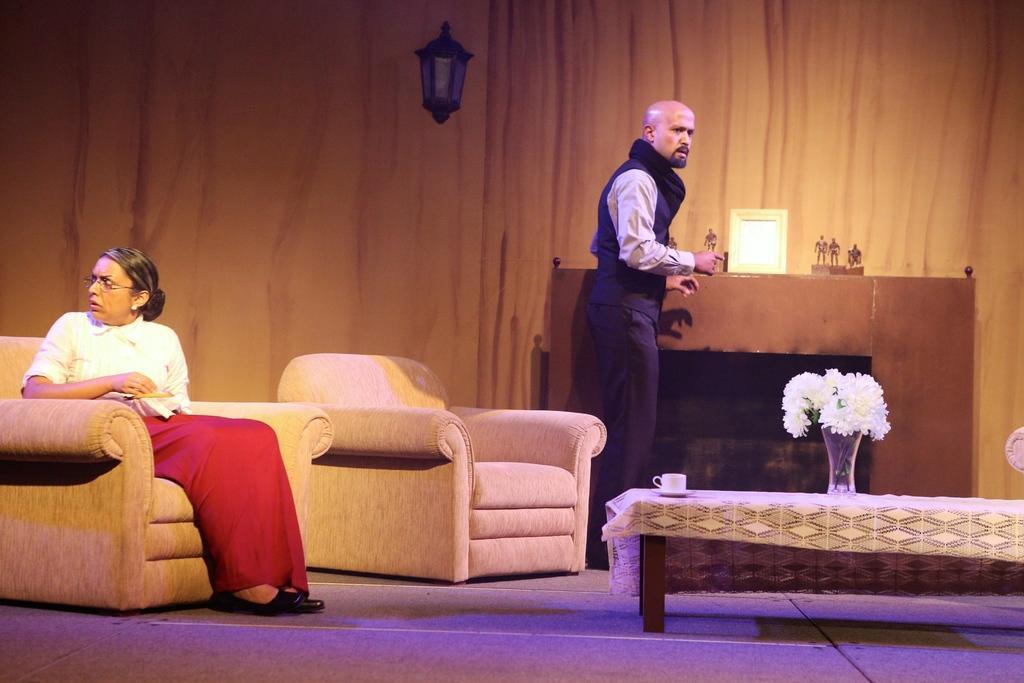Describe this image in one or two sentences. In this picture, we see a man and woman. man standing on a woman seated in a chair and we see a table. On the table,We see a cup and a flower pot 